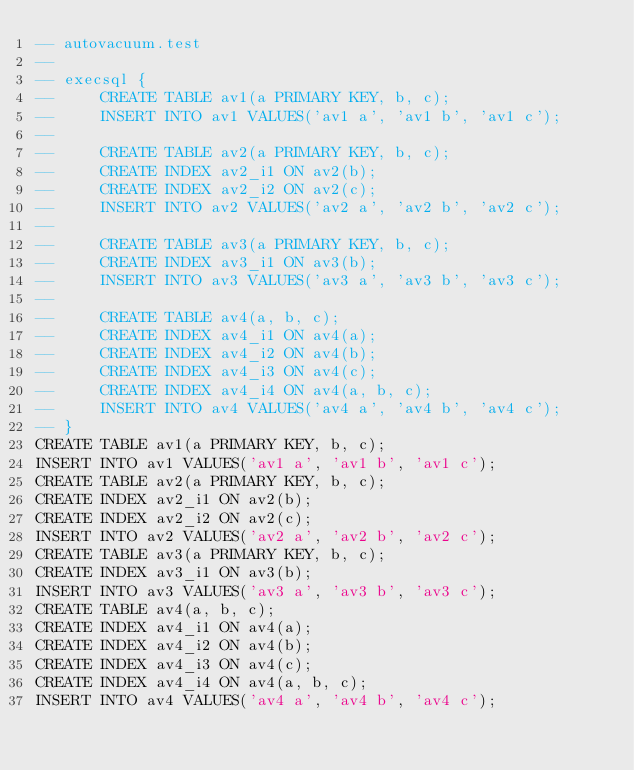Convert code to text. <code><loc_0><loc_0><loc_500><loc_500><_SQL_>-- autovacuum.test
-- 
-- execsql {
--     CREATE TABLE av1(a PRIMARY KEY, b, c);
--     INSERT INTO av1 VALUES('av1 a', 'av1 b', 'av1 c');
-- 
--     CREATE TABLE av2(a PRIMARY KEY, b, c);
--     CREATE INDEX av2_i1 ON av2(b);
--     CREATE INDEX av2_i2 ON av2(c);
--     INSERT INTO av2 VALUES('av2 a', 'av2 b', 'av2 c');
-- 
--     CREATE TABLE av3(a PRIMARY KEY, b, c);
--     CREATE INDEX av3_i1 ON av3(b);
--     INSERT INTO av3 VALUES('av3 a', 'av3 b', 'av3 c');
-- 
--     CREATE TABLE av4(a, b, c);
--     CREATE INDEX av4_i1 ON av4(a);
--     CREATE INDEX av4_i2 ON av4(b);
--     CREATE INDEX av4_i3 ON av4(c);
--     CREATE INDEX av4_i4 ON av4(a, b, c);
--     INSERT INTO av4 VALUES('av4 a', 'av4 b', 'av4 c');
-- }
CREATE TABLE av1(a PRIMARY KEY, b, c);
INSERT INTO av1 VALUES('av1 a', 'av1 b', 'av1 c');
CREATE TABLE av2(a PRIMARY KEY, b, c);
CREATE INDEX av2_i1 ON av2(b);
CREATE INDEX av2_i2 ON av2(c);
INSERT INTO av2 VALUES('av2 a', 'av2 b', 'av2 c');
CREATE TABLE av3(a PRIMARY KEY, b, c);
CREATE INDEX av3_i1 ON av3(b);
INSERT INTO av3 VALUES('av3 a', 'av3 b', 'av3 c');
CREATE TABLE av4(a, b, c);
CREATE INDEX av4_i1 ON av4(a);
CREATE INDEX av4_i2 ON av4(b);
CREATE INDEX av4_i3 ON av4(c);
CREATE INDEX av4_i4 ON av4(a, b, c);
INSERT INTO av4 VALUES('av4 a', 'av4 b', 'av4 c');</code> 